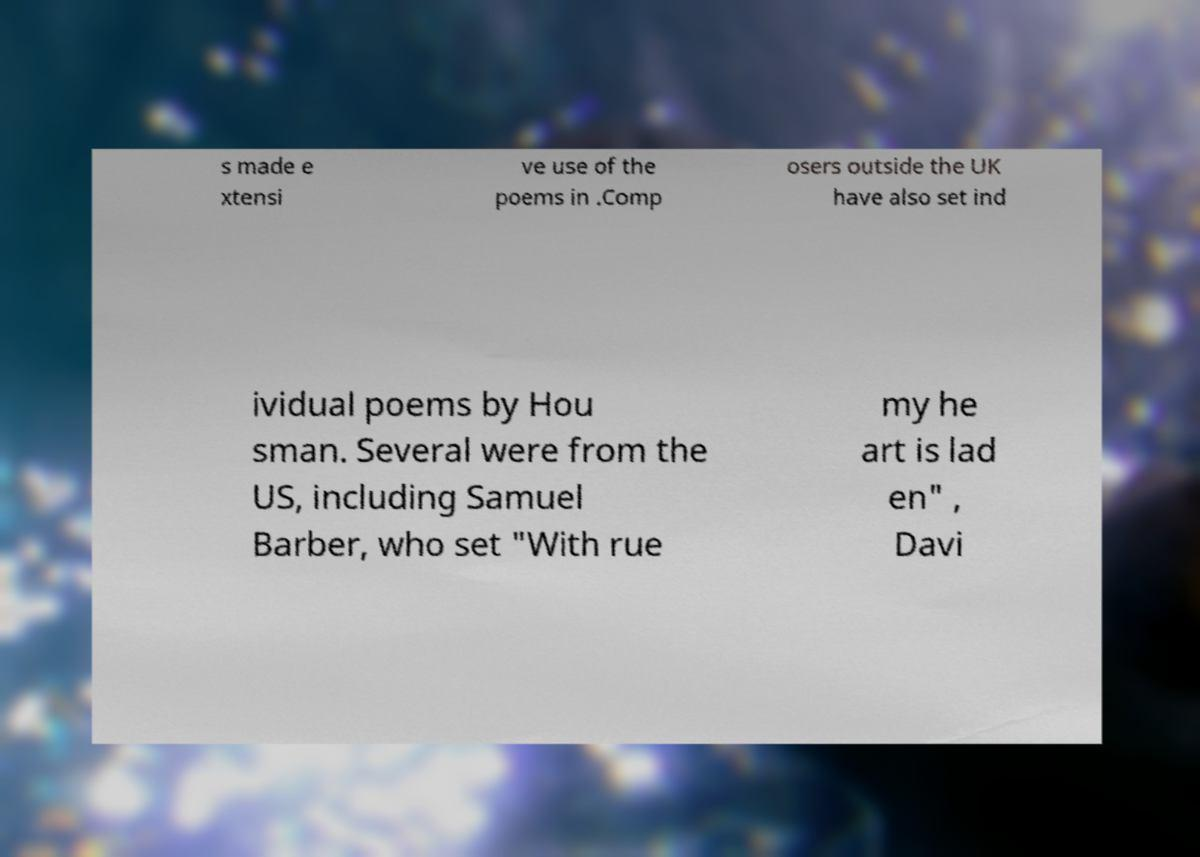Please read and relay the text visible in this image. What does it say? s made e xtensi ve use of the poems in .Comp osers outside the UK have also set ind ividual poems by Hou sman. Several were from the US, including Samuel Barber, who set "With rue my he art is lad en" , Davi 